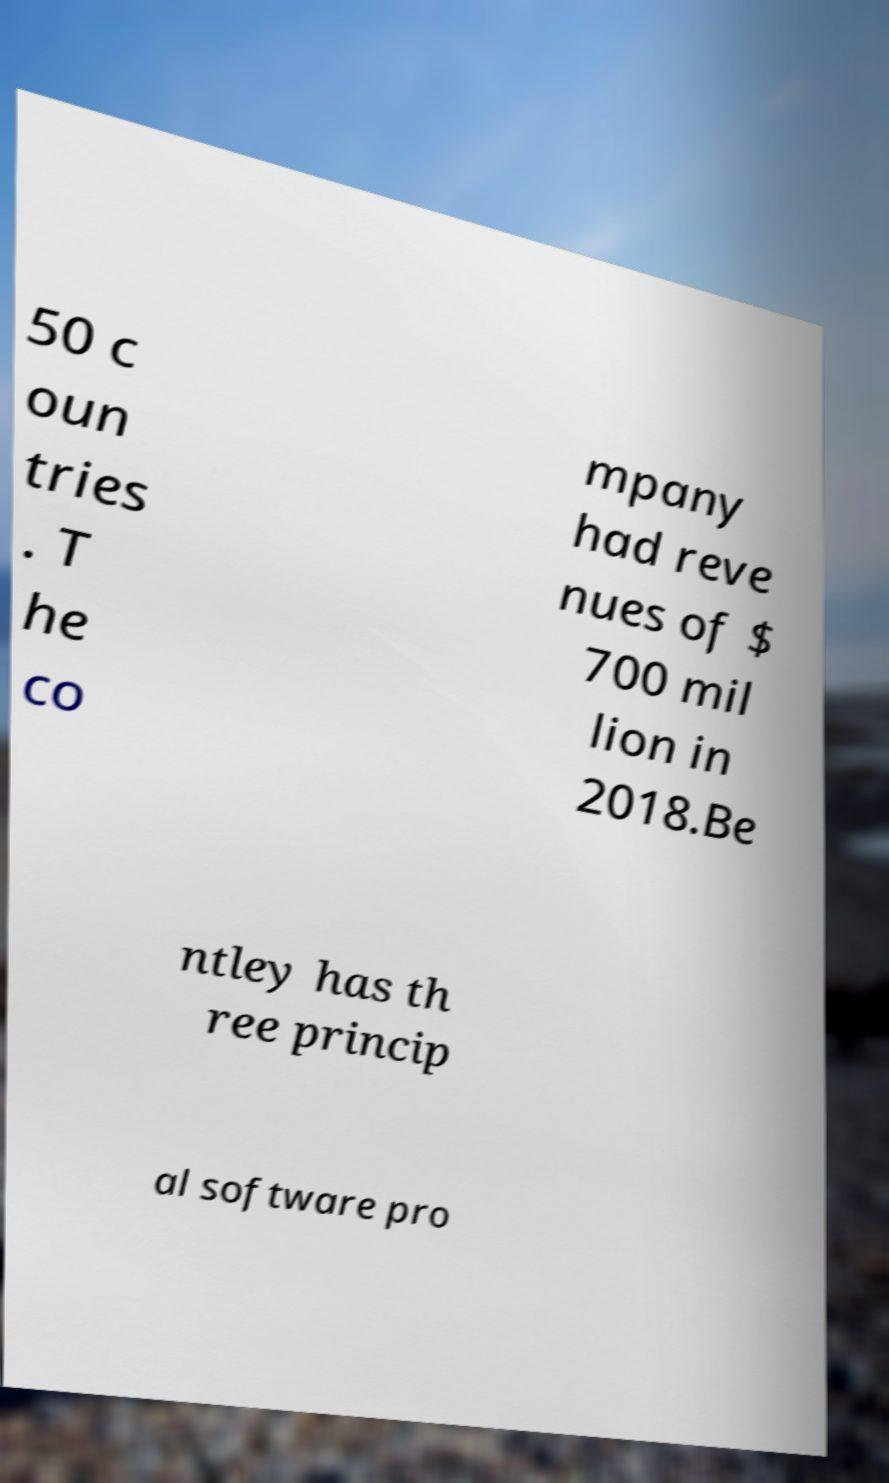I need the written content from this picture converted into text. Can you do that? 50 c oun tries . T he co mpany had reve nues of $ 700 mil lion in 2018.Be ntley has th ree princip al software pro 